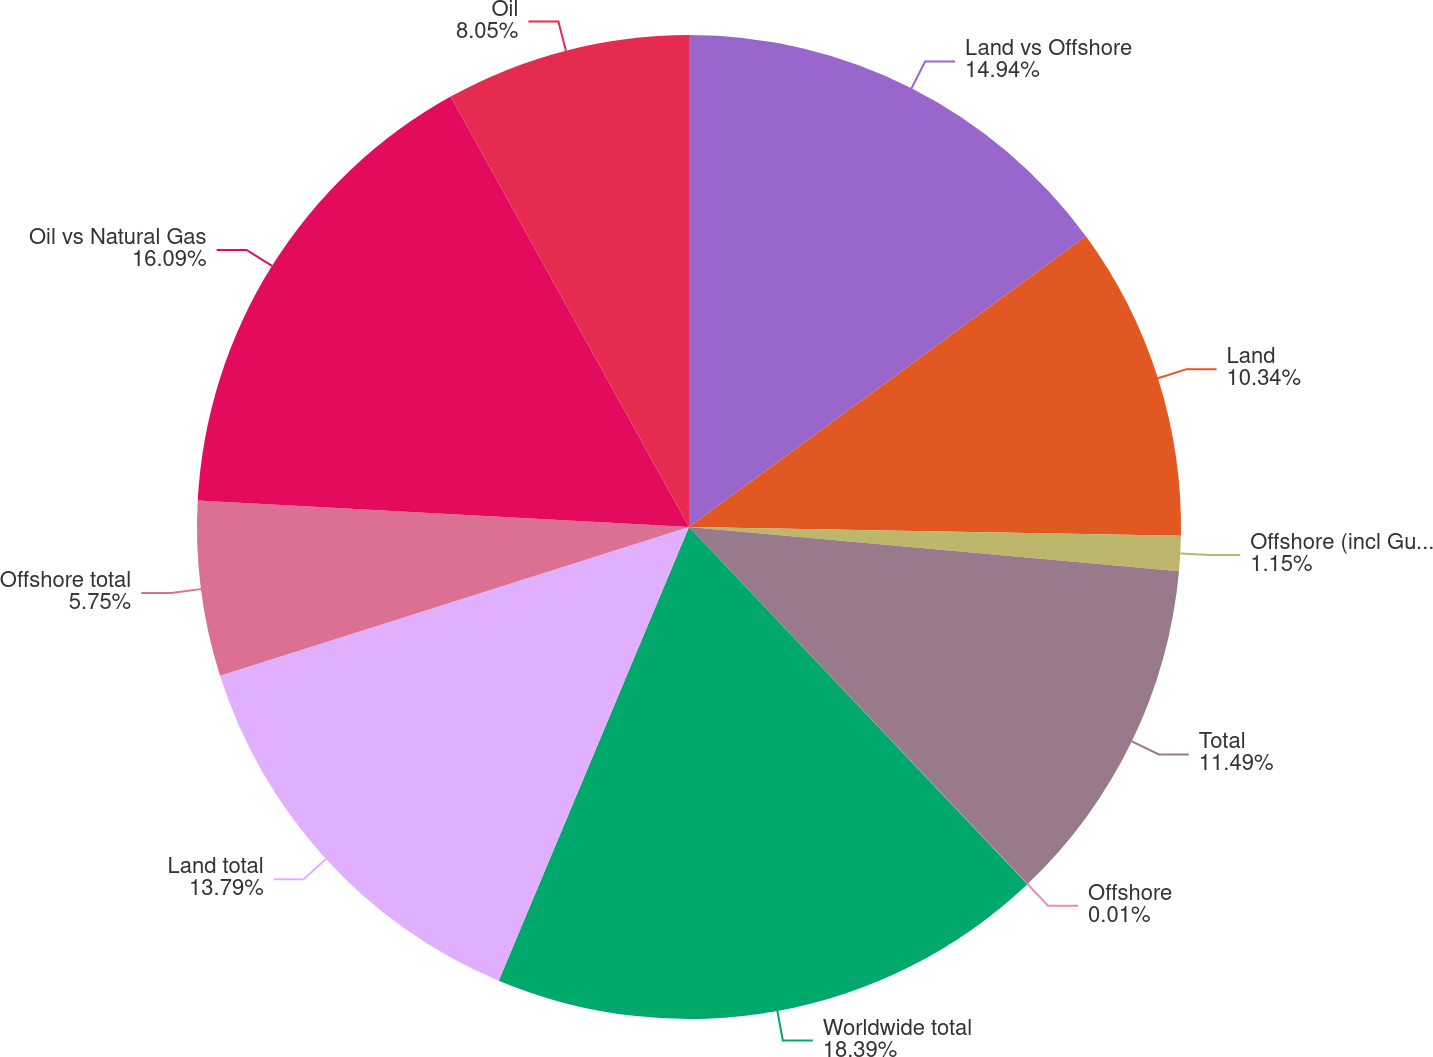Convert chart. <chart><loc_0><loc_0><loc_500><loc_500><pie_chart><fcel>Land vs Offshore<fcel>Land<fcel>Offshore (incl Gulf of Mexico)<fcel>Total<fcel>Offshore<fcel>Worldwide total<fcel>Land total<fcel>Offshore total<fcel>Oil vs Natural Gas<fcel>Oil<nl><fcel>14.94%<fcel>10.34%<fcel>1.15%<fcel>11.49%<fcel>0.01%<fcel>18.39%<fcel>13.79%<fcel>5.75%<fcel>16.09%<fcel>8.05%<nl></chart> 